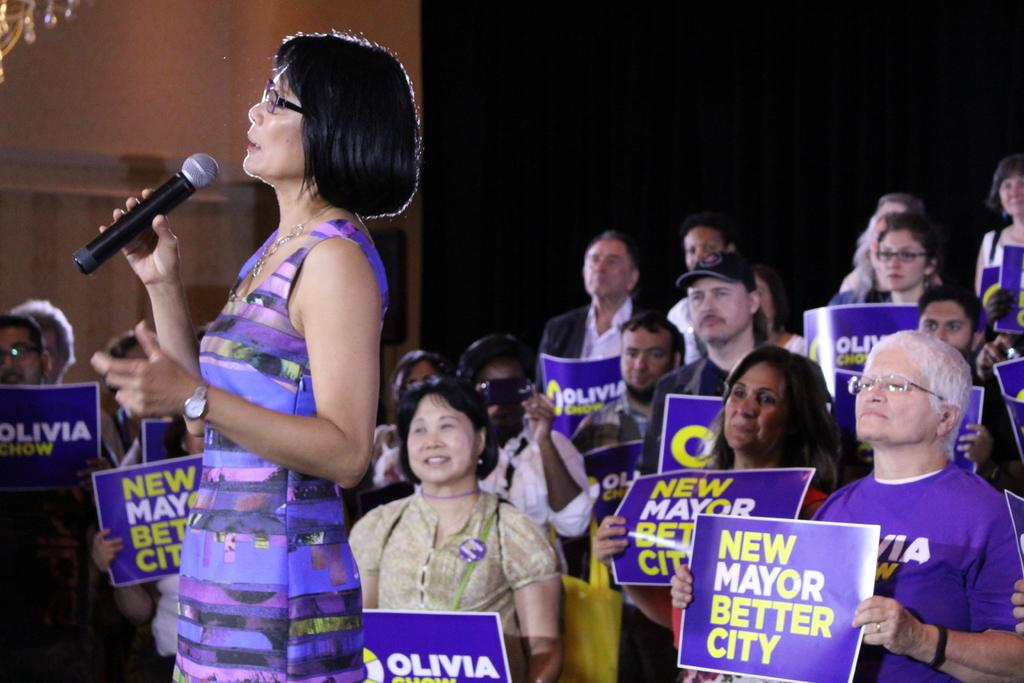What is the main subject of the image? There is a woman in the image. What is the woman doing in the image? The woman is standing and holding a microphone. Can you describe the people in the background of the image? The people in the background are holding papers. What flavor of ear can be seen on the woman in the image? There is no ear visible on the woman in the image, and therefore no flavor can be associated with it. 